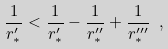<formula> <loc_0><loc_0><loc_500><loc_500>\frac { 1 } { r _ { * } ^ { \prime } } < \frac { 1 } { r _ { * } ^ { \prime } } - \frac { 1 } { r _ { * } ^ { \prime \prime } } + \frac { 1 } { r _ { * } ^ { \prime \prime \prime } } \ ,</formula> 